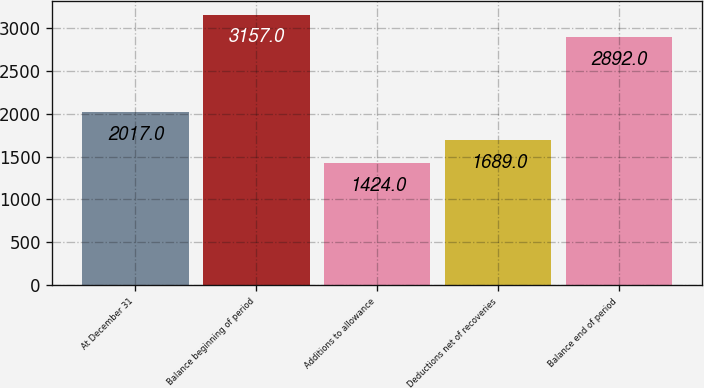<chart> <loc_0><loc_0><loc_500><loc_500><bar_chart><fcel>At December 31<fcel>Balance beginning of period<fcel>Additions to allowance<fcel>Deductions net of recoveries<fcel>Balance end of period<nl><fcel>2017<fcel>3157<fcel>1424<fcel>1689<fcel>2892<nl></chart> 